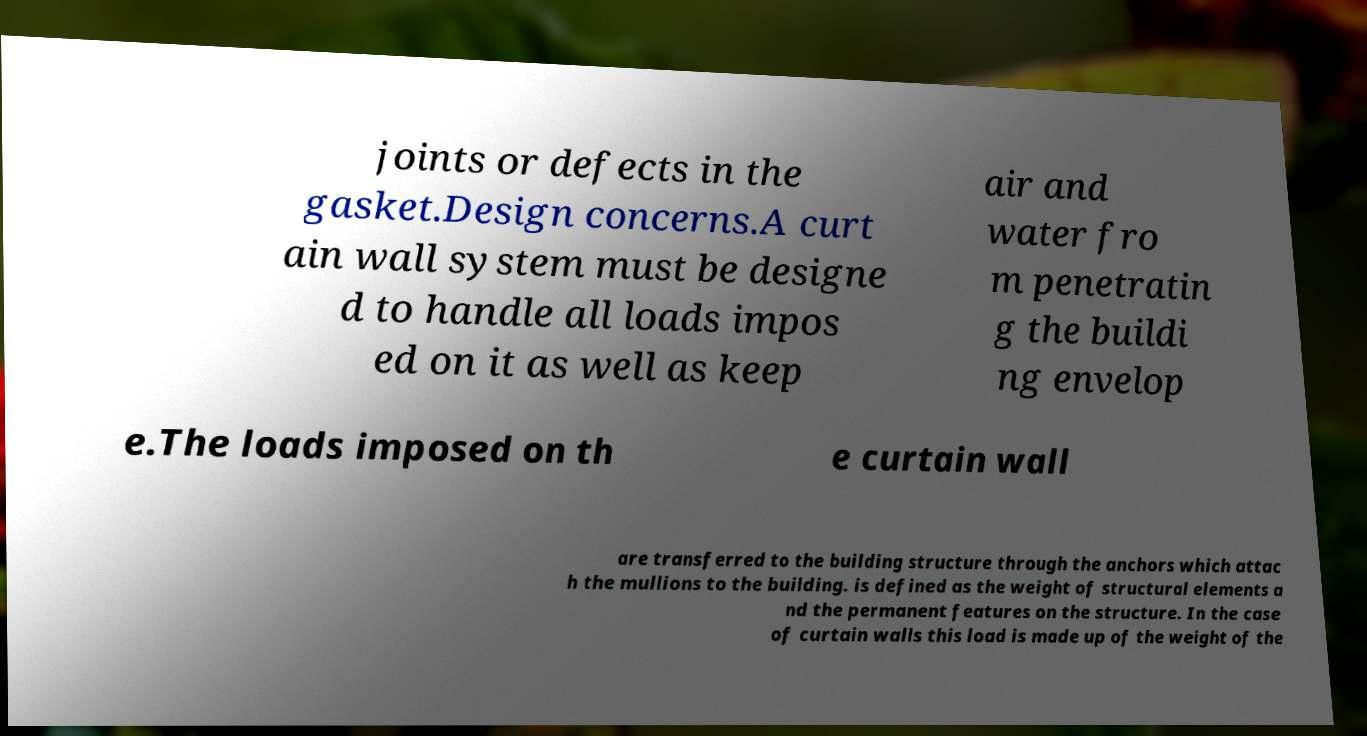For documentation purposes, I need the text within this image transcribed. Could you provide that? joints or defects in the gasket.Design concerns.A curt ain wall system must be designe d to handle all loads impos ed on it as well as keep air and water fro m penetratin g the buildi ng envelop e.The loads imposed on th e curtain wall are transferred to the building structure through the anchors which attac h the mullions to the building. is defined as the weight of structural elements a nd the permanent features on the structure. In the case of curtain walls this load is made up of the weight of the 